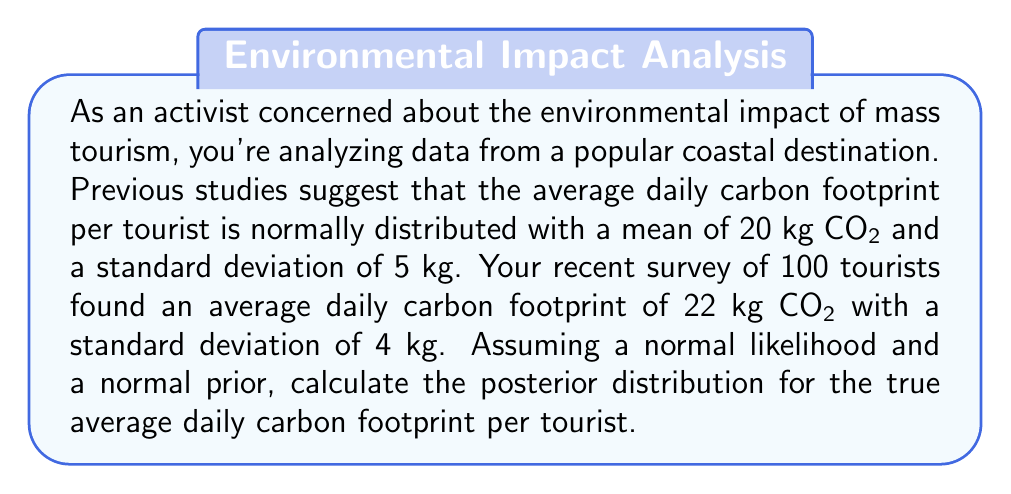Teach me how to tackle this problem. To solve this problem, we'll use Bayesian inference with conjugate priors. Since both the prior and likelihood are normal distributions, the posterior will also be normal.

1. Define the prior distribution:
   $\mu_0 = 20$ (prior mean)
   $\sigma_0 = 5$ (prior standard deviation)
   $\tau_0 = 1/\sigma_0^2 = 1/25 = 0.04$ (prior precision)

2. Define the likelihood:
   $\bar{x} = 22$ (sample mean)
   $s = 4$ (sample standard deviation)
   $n = 100$ (sample size)
   $\tau = n/s^2 = 100/16 = 6.25$ (likelihood precision)

3. Calculate the posterior parameters using the following formulas:
   $$\tau_n = \tau_0 + \tau$$
   $$\mu_n = \frac{\tau_0\mu_0 + \tau\bar{x}}{\tau_n}$$

4. Substitute the values:
   $$\tau_n = 0.04 + 6.25 = 6.29$$
   $$\mu_n = \frac{0.04 \cdot 20 + 6.25 \cdot 22}{6.29} = 21.97$$

5. Calculate the posterior standard deviation:
   $$\sigma_n = \sqrt{\frac{1}{\tau_n}} = \sqrt{\frac{1}{6.29}} \approx 0.3987$$

Therefore, the posterior distribution is normal with mean $\mu_n = 21.97$ and standard deviation $\sigma_n \approx 0.3987$.
Answer: The posterior distribution for the true average daily carbon footprint per tourist is $N(21.97, 0.3987^2)$. 